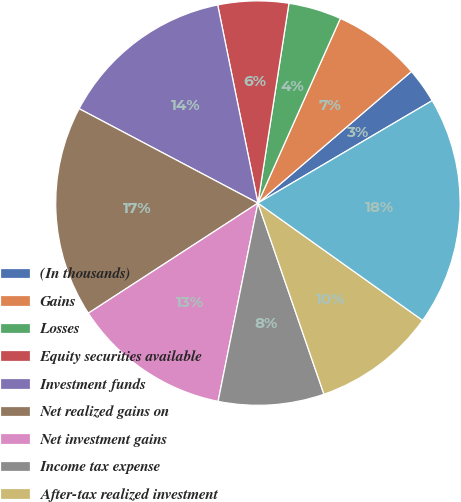<chart> <loc_0><loc_0><loc_500><loc_500><pie_chart><fcel>(In thousands)<fcel>Gains<fcel>Losses<fcel>Equity securities available<fcel>Investment funds<fcel>Net realized gains on<fcel>Net investment gains<fcel>Income tax expense<fcel>After-tax realized investment<fcel>Fixed maturity securities<nl><fcel>2.82%<fcel>7.04%<fcel>4.23%<fcel>5.64%<fcel>14.08%<fcel>16.9%<fcel>12.68%<fcel>8.45%<fcel>9.86%<fcel>18.31%<nl></chart> 